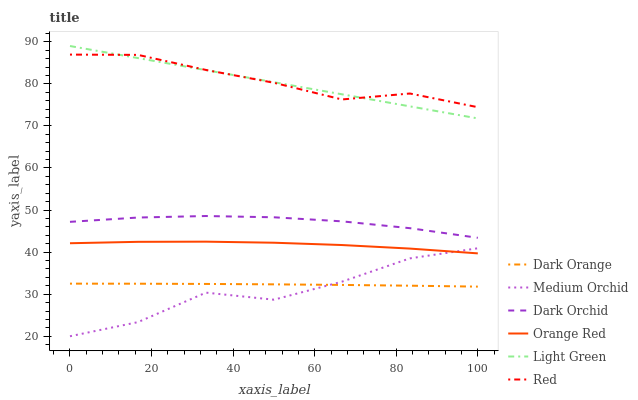Does Medium Orchid have the minimum area under the curve?
Answer yes or no. Yes. Does Red have the maximum area under the curve?
Answer yes or no. Yes. Does Dark Orchid have the minimum area under the curve?
Answer yes or no. No. Does Dark Orchid have the maximum area under the curve?
Answer yes or no. No. Is Light Green the smoothest?
Answer yes or no. Yes. Is Medium Orchid the roughest?
Answer yes or no. Yes. Is Dark Orchid the smoothest?
Answer yes or no. No. Is Dark Orchid the roughest?
Answer yes or no. No. Does Dark Orchid have the lowest value?
Answer yes or no. No. Does Medium Orchid have the highest value?
Answer yes or no. No. Is Dark Orange less than Dark Orchid?
Answer yes or no. Yes. Is Red greater than Orange Red?
Answer yes or no. Yes. Does Dark Orange intersect Dark Orchid?
Answer yes or no. No. 